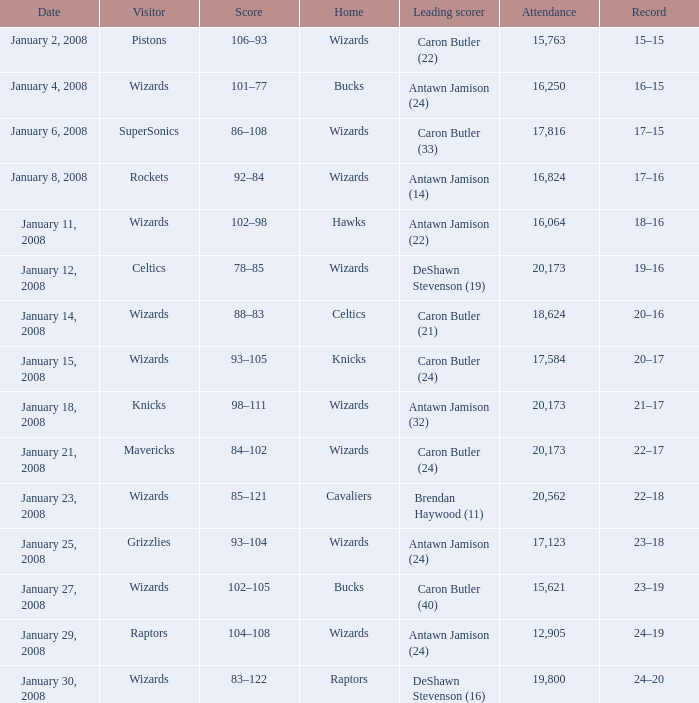What was the attendance count on january 4, 2008? 16250.0. 